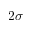<formula> <loc_0><loc_0><loc_500><loc_500>2 \sigma</formula> 